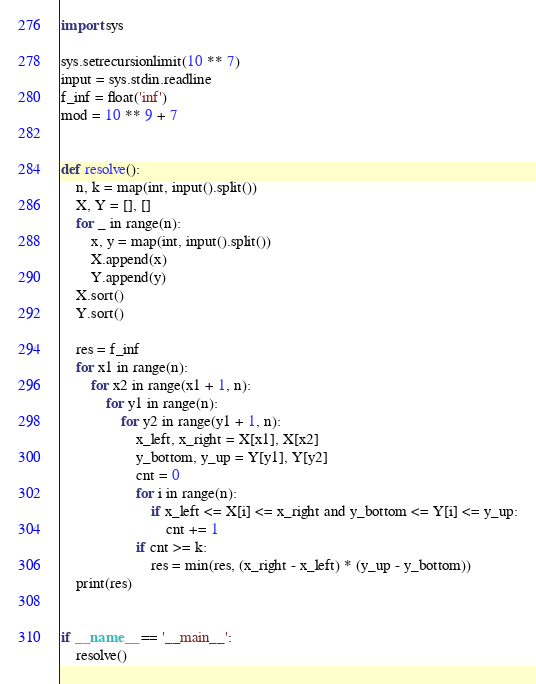<code> <loc_0><loc_0><loc_500><loc_500><_Python_>import sys

sys.setrecursionlimit(10 ** 7)
input = sys.stdin.readline
f_inf = float('inf')
mod = 10 ** 9 + 7


def resolve():
    n, k = map(int, input().split())
    X, Y = [], []
    for _ in range(n):
        x, y = map(int, input().split())
        X.append(x)
        Y.append(y)
    X.sort()
    Y.sort()

    res = f_inf
    for x1 in range(n):
        for x2 in range(x1 + 1, n):
            for y1 in range(n):
                for y2 in range(y1 + 1, n):
                    x_left, x_right = X[x1], X[x2]
                    y_bottom, y_up = Y[y1], Y[y2]
                    cnt = 0
                    for i in range(n):
                        if x_left <= X[i] <= x_right and y_bottom <= Y[i] <= y_up:
                            cnt += 1
                    if cnt >= k:
                        res = min(res, (x_right - x_left) * (y_up - y_bottom))
    print(res)


if __name__ == '__main__':
    resolve()
</code> 